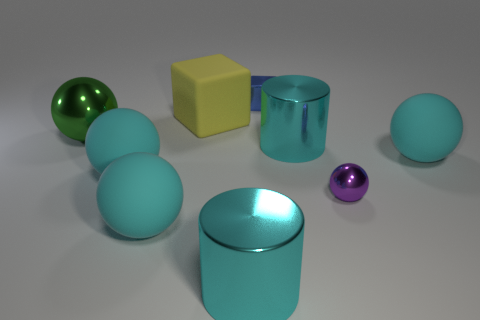Are there any other things that have the same size as the purple shiny ball?
Provide a succinct answer. Yes. There is a metallic cube that is the same size as the purple shiny sphere; what color is it?
Your answer should be very brief. Blue. There is a large cylinder that is to the right of the small metallic block; is there a large yellow cube that is right of it?
Offer a terse response. No. There is a cyan ball to the right of the yellow object; what material is it?
Provide a short and direct response. Rubber. Does the large thing that is behind the big green metallic sphere have the same material as the tiny object in front of the large green sphere?
Give a very brief answer. No. Is the number of tiny purple metallic spheres right of the tiny sphere the same as the number of small metal objects that are in front of the metallic cube?
Your answer should be compact. No. What number of green things are the same material as the blue object?
Offer a very short reply. 1. What is the size of the matte object behind the green metallic thing to the left of the small metal ball?
Provide a succinct answer. Large. Do the small thing that is in front of the yellow matte object and the big cyan rubber object right of the tiny metallic cube have the same shape?
Provide a succinct answer. Yes. Are there the same number of big cyan things that are to the left of the green metallic object and small blue metallic things?
Make the answer very short. No. 